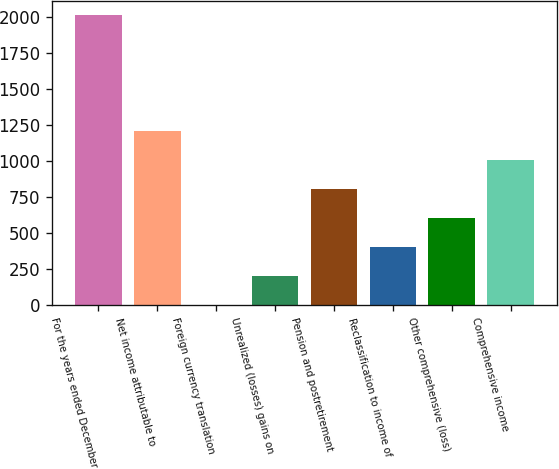<chart> <loc_0><loc_0><loc_500><loc_500><bar_chart><fcel>For the years ended December<fcel>Net income attributable to<fcel>Foreign currency translation<fcel>Unrealized (losses) gains on<fcel>Pension and postretirement<fcel>Reclassification to income of<fcel>Other comprehensive (loss)<fcel>Comprehensive income<nl><fcel>2014<fcel>1209.2<fcel>2<fcel>203.2<fcel>806.8<fcel>404.4<fcel>605.6<fcel>1008<nl></chart> 